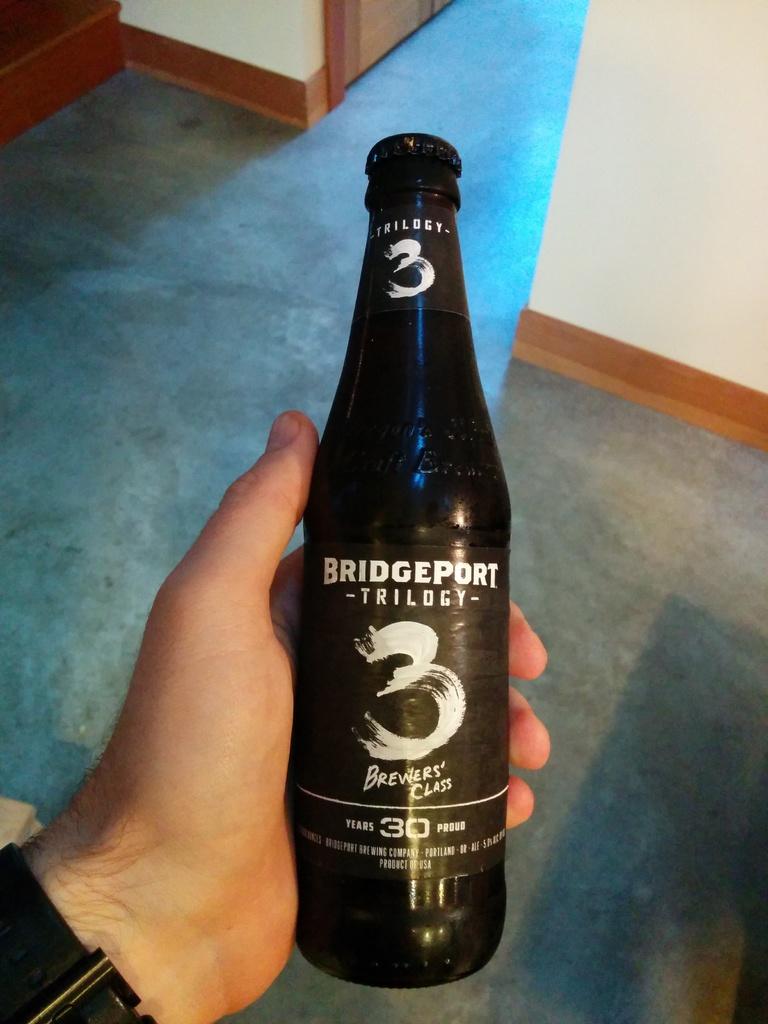What number is on the label of that beer?
Provide a succinct answer. 3. What is the brand name?
Offer a terse response. Bridgeport. 